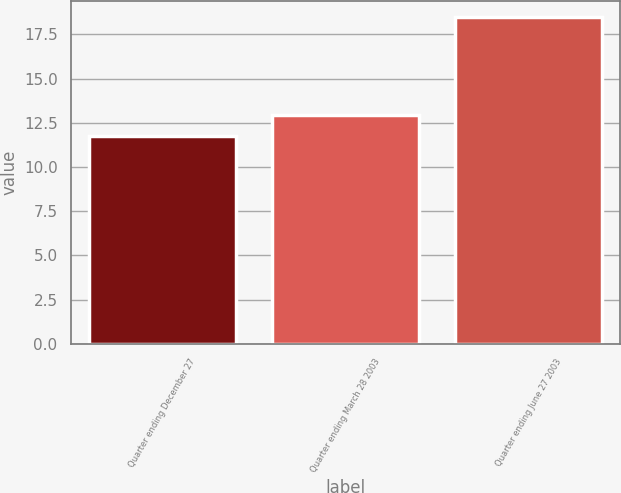<chart> <loc_0><loc_0><loc_500><loc_500><bar_chart><fcel>Quarter ending December 27<fcel>Quarter ending March 28 2003<fcel>Quarter ending June 27 2003<nl><fcel>11.78<fcel>12.95<fcel>18.49<nl></chart> 